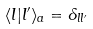Convert formula to latex. <formula><loc_0><loc_0><loc_500><loc_500>\langle l | l ^ { \prime } \rangle _ { a } = \delta _ { l l ^ { \prime } }</formula> 